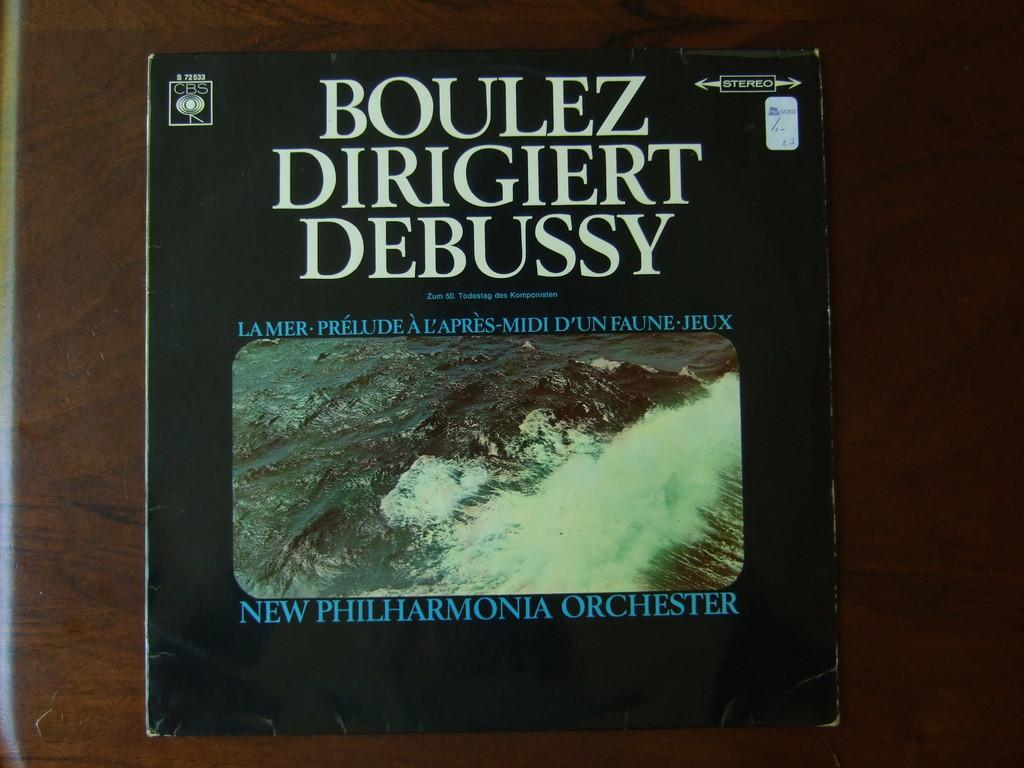<image>
Write a terse but informative summary of the picture. A CD cover features works by Boulez, Dirigiert and Debussy. 